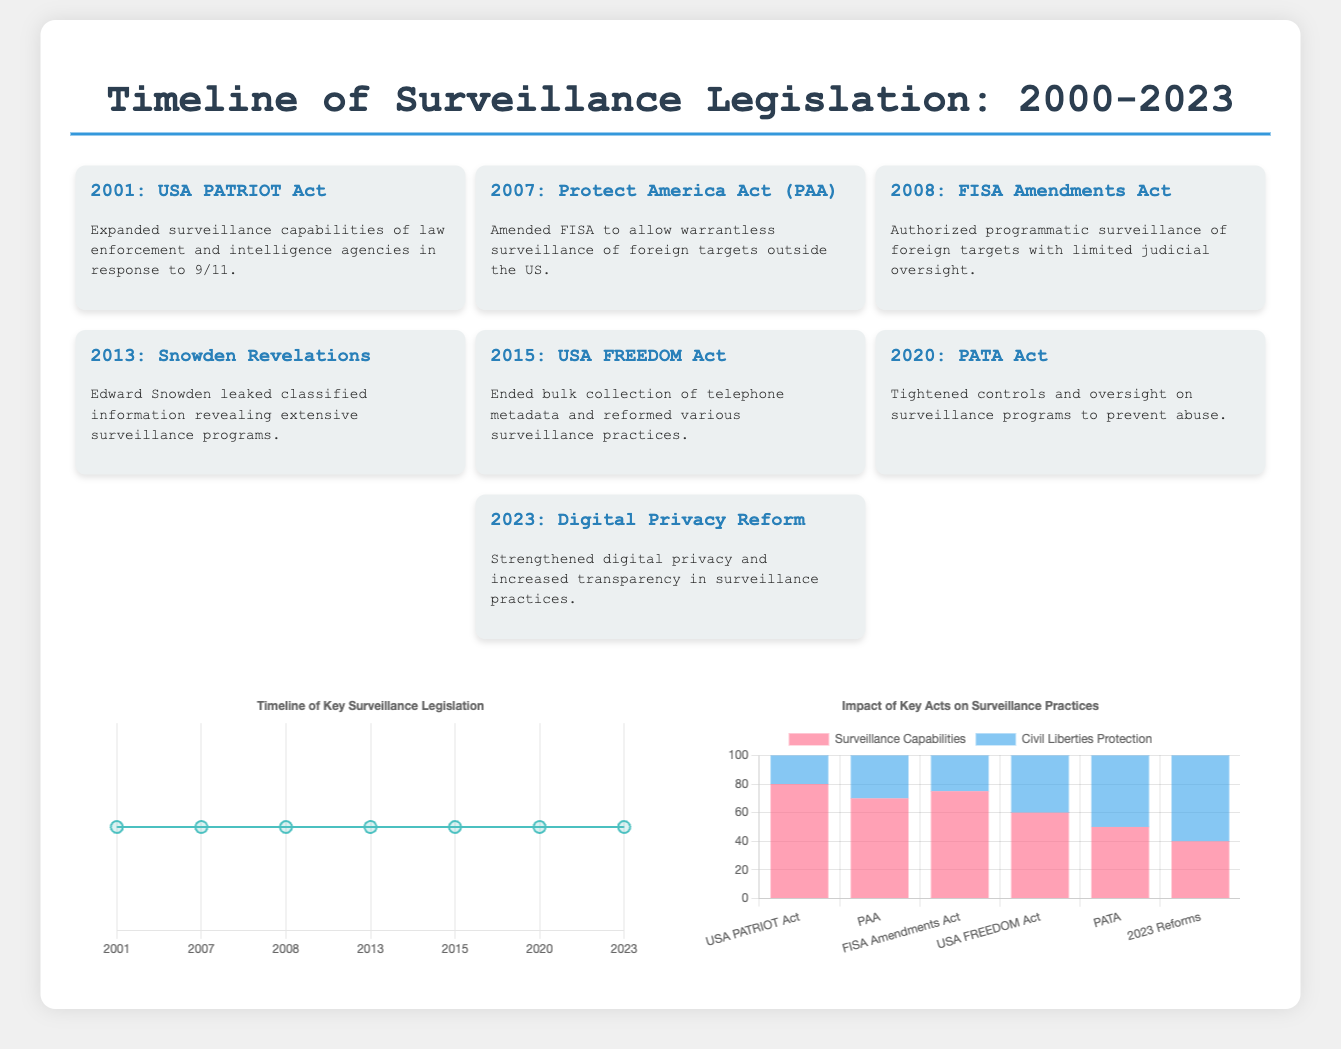What year was the USA PATRIOT Act enacted? The USA PATRIOT Act was enacted in 2001, as indicated in the timeline section of the document.
Answer: 2001 What significant event occurred in 2013? The significant event in 2013 was the Snowden Revelations, which is mentioned in the timeline.
Answer: Snowden Revelations How many key legislation events are listed in the timeline? The timeline has seven key legislation events from 2001 to 2023 as indicated by the number of events detailed in the document.
Answer: 7 What was the impact score for Civil Liberties Protection after the 2023 reforms? The impact score for Civil Liberties Protection after the 2023 reforms is mentioned in the Impact Chart, which shows a value of 60.
Answer: 60 Which act ended bulk collection of telephone metadata? The act that ended bulk collection of telephone metadata is the USA FREEDOM Act, as stated in the timeline section.
Answer: USA FREEDOM Act What does the chart on the right illustrate? The chart on the right illustrates the impact of key acts on surveillance practices, based on data presented in the Impact Chart section.
Answer: Impact of Key Acts on Surveillance Practices Which act was passed in 2020? The act passed in 2020 was the PATA Act, as shown in the timeline events.
Answer: PATA Act What color is used to represent Civil Liberties Protection in the Impact Chart? Civil Liberties Protection is represented in blue in the Impact Chart, according to the data visualization provided.
Answer: Blue 